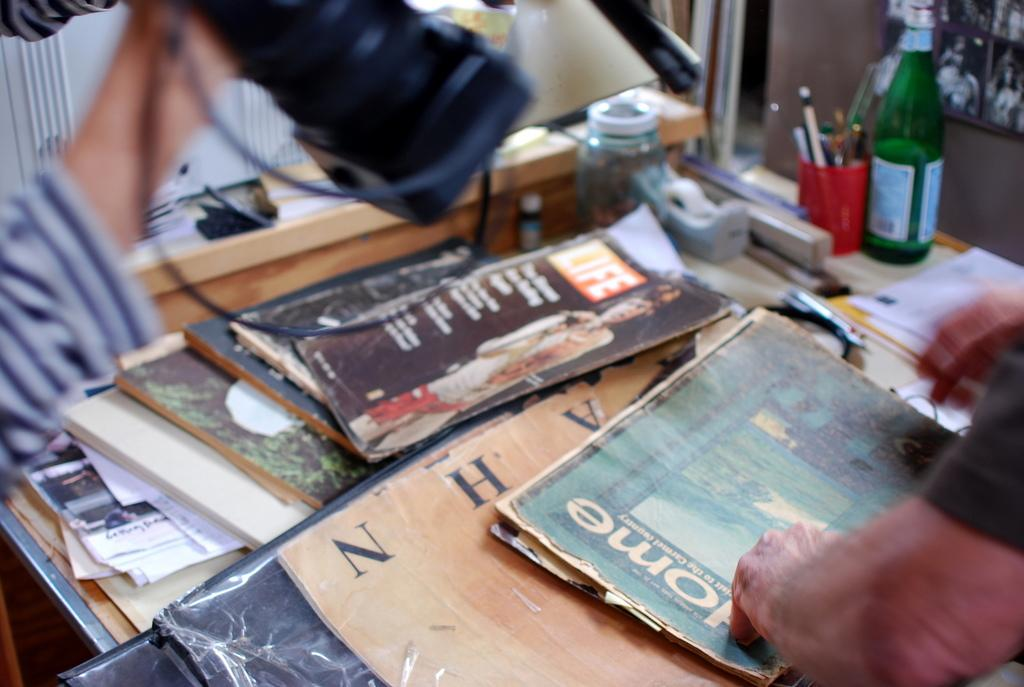<image>
Provide a brief description of the given image. Person touching a cover with the letters "ome" on it. 